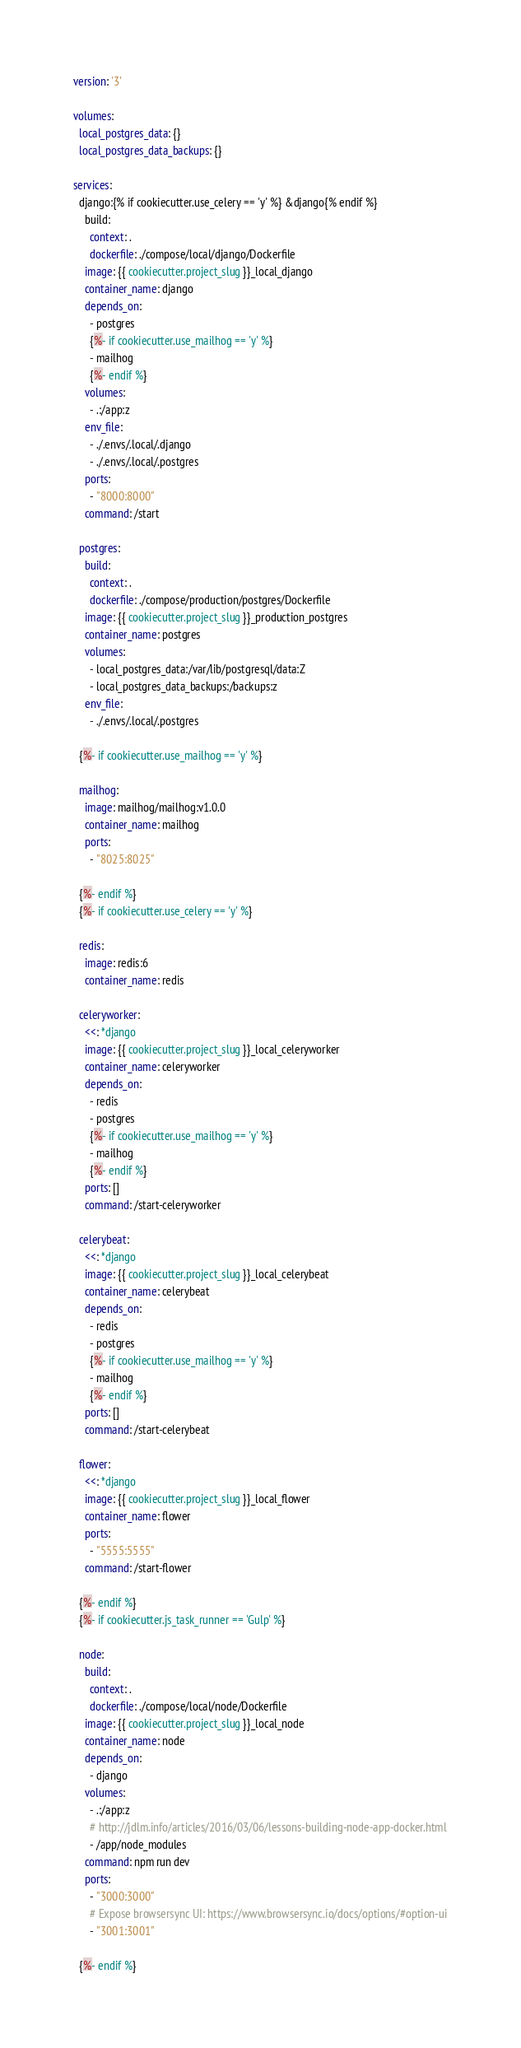Convert code to text. <code><loc_0><loc_0><loc_500><loc_500><_YAML_>version: '3'

volumes:
  local_postgres_data: {}
  local_postgres_data_backups: {}

services:
  django:{% if cookiecutter.use_celery == 'y' %} &django{% endif %}
    build:
      context: .
      dockerfile: ./compose/local/django/Dockerfile
    image: {{ cookiecutter.project_slug }}_local_django
    container_name: django
    depends_on:
      - postgres
      {%- if cookiecutter.use_mailhog == 'y' %}
      - mailhog
      {%- endif %}
    volumes:
      - .:/app:z
    env_file:
      - ./.envs/.local/.django
      - ./.envs/.local/.postgres
    ports:
      - "8000:8000"
    command: /start

  postgres:
    build:
      context: .
      dockerfile: ./compose/production/postgres/Dockerfile
    image: {{ cookiecutter.project_slug }}_production_postgres
    container_name: postgres
    volumes:
      - local_postgres_data:/var/lib/postgresql/data:Z
      - local_postgres_data_backups:/backups:z
    env_file:
      - ./.envs/.local/.postgres

  {%- if cookiecutter.use_mailhog == 'y' %}

  mailhog:
    image: mailhog/mailhog:v1.0.0
    container_name: mailhog
    ports:
      - "8025:8025"

  {%- endif %}
  {%- if cookiecutter.use_celery == 'y' %}

  redis:
    image: redis:6
    container_name: redis

  celeryworker:
    <<: *django
    image: {{ cookiecutter.project_slug }}_local_celeryworker
    container_name: celeryworker
    depends_on:
      - redis
      - postgres
      {%- if cookiecutter.use_mailhog == 'y' %}
      - mailhog
      {%- endif %}
    ports: []
    command: /start-celeryworker

  celerybeat:
    <<: *django
    image: {{ cookiecutter.project_slug }}_local_celerybeat
    container_name: celerybeat
    depends_on:
      - redis
      - postgres
      {%- if cookiecutter.use_mailhog == 'y' %}
      - mailhog
      {%- endif %}
    ports: []
    command: /start-celerybeat

  flower:
    <<: *django
    image: {{ cookiecutter.project_slug }}_local_flower
    container_name: flower
    ports:
      - "5555:5555"
    command: /start-flower

  {%- endif %}
  {%- if cookiecutter.js_task_runner == 'Gulp' %}

  node:
    build:
      context: .
      dockerfile: ./compose/local/node/Dockerfile
    image: {{ cookiecutter.project_slug }}_local_node
    container_name: node
    depends_on:
      - django
    volumes:
      - .:/app:z
      # http://jdlm.info/articles/2016/03/06/lessons-building-node-app-docker.html
      - /app/node_modules
    command: npm run dev
    ports:
      - "3000:3000"
      # Expose browsersync UI: https://www.browsersync.io/docs/options/#option-ui
      - "3001:3001"

  {%- endif %}
</code> 